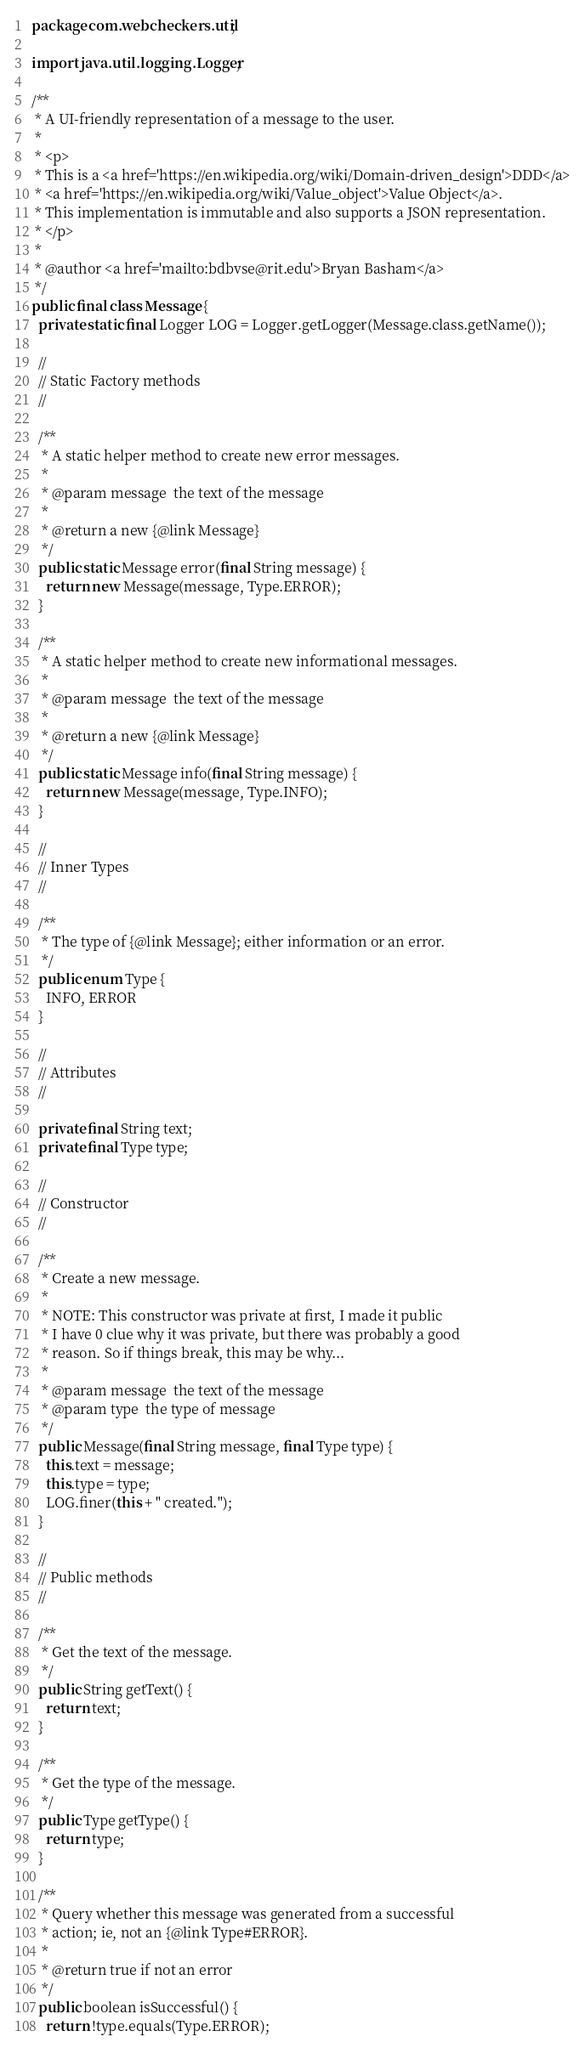Convert code to text. <code><loc_0><loc_0><loc_500><loc_500><_Java_>package com.webcheckers.util;

import java.util.logging.Logger;

/**
 * A UI-friendly representation of a message to the user.
 *
 * <p>
 * This is a <a href='https://en.wikipedia.org/wiki/Domain-driven_design'>DDD</a>
 * <a href='https://en.wikipedia.org/wiki/Value_object'>Value Object</a>.
 * This implementation is immutable and also supports a JSON representation.
 * </p>
 *
 * @author <a href='mailto:bdbvse@rit.edu'>Bryan Basham</a>
 */
public final class Message {
  private static final Logger LOG = Logger.getLogger(Message.class.getName());

  //
  // Static Factory methods
  //

  /**
   * A static helper method to create new error messages.
   *
   * @param message  the text of the message
   *
   * @return a new {@link Message}
   */
  public static Message error(final String message) {
    return new Message(message, Type.ERROR);
  }

  /**
   * A static helper method to create new informational messages.
   *
   * @param message  the text of the message
   *
   * @return a new {@link Message}
   */
  public static Message info(final String message) {
    return new Message(message, Type.INFO);
  }

  //
  // Inner Types
  //

  /**
   * The type of {@link Message}; either information or an error.
   */
  public enum Type {
    INFO, ERROR
  }

  //
  // Attributes
  //

  private final String text;
  private final Type type;

  //
  // Constructor
  //

  /**
   * Create a new message.
   *
   * NOTE: This constructor was private at first, I made it public
   * I have 0 clue why it was private, but there was probably a good
   * reason. So if things break, this may be why...
   * 
   * @param message  the text of the message
   * @param type  the type of message
   */
  public Message(final String message, final Type type) {
    this.text = message;
    this.type = type;
    LOG.finer(this + " created.");
  }

  //
  // Public methods
  //

  /**
   * Get the text of the message.
   */
  public String getText() {
    return text;
  }

  /**
   * Get the type of the message.
   */
  public Type getType() {
    return type;
  }

  /**
   * Query whether this message was generated from a successful
   * action; ie, not an {@link Type#ERROR}.
   *
   * @return true if not an error
   */
  public boolean isSuccessful() {
    return !type.equals(Type.ERROR);</code> 